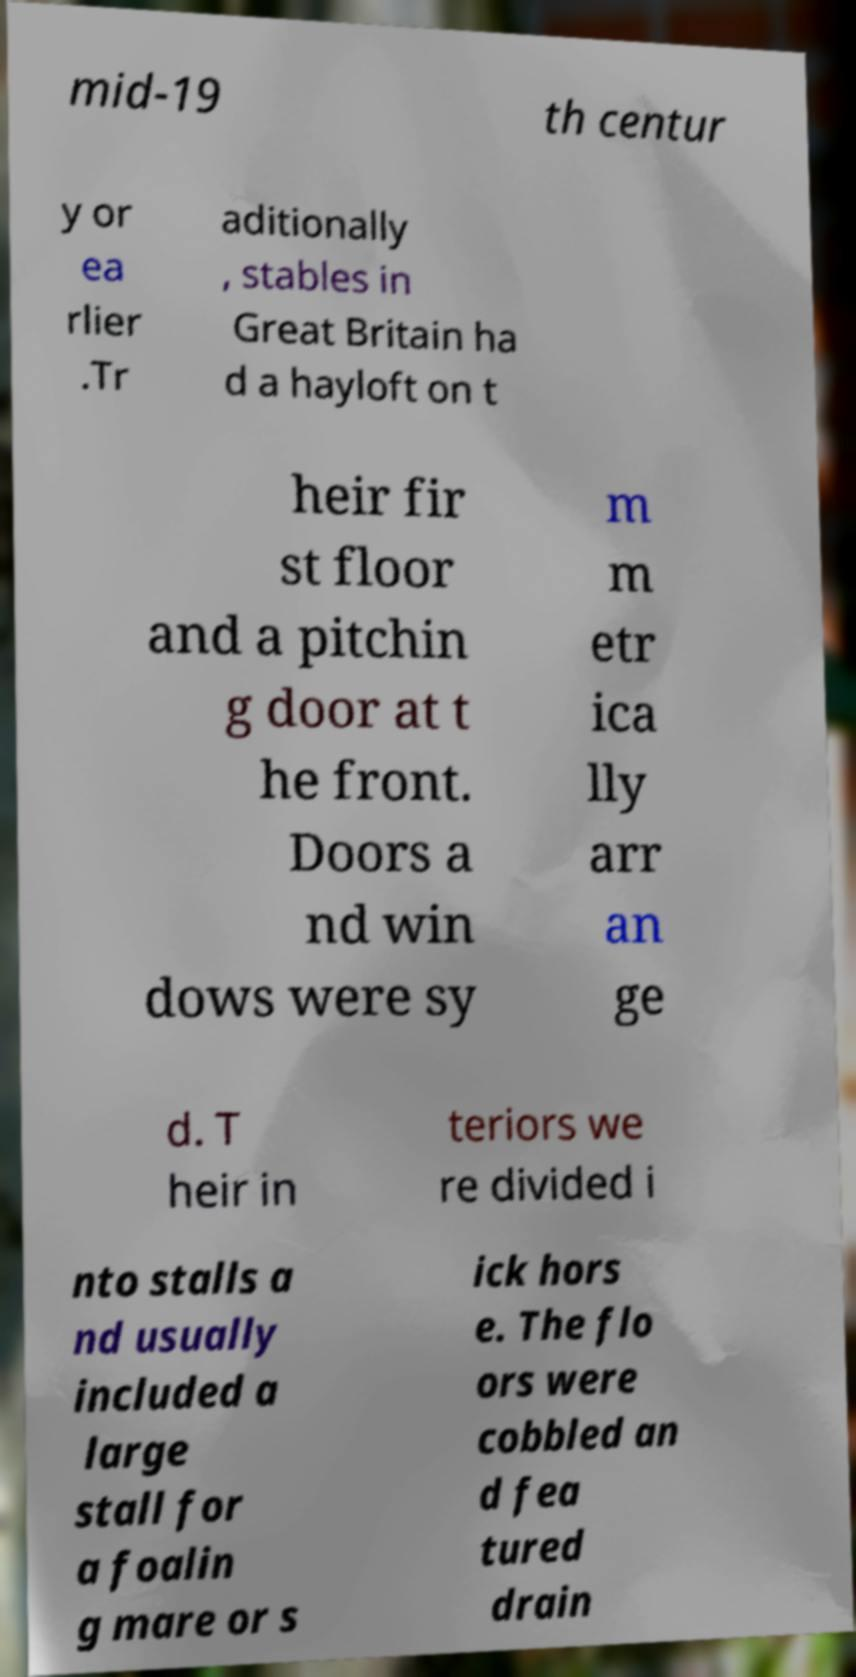Could you extract and type out the text from this image? mid-19 th centur y or ea rlier .Tr aditionally , stables in Great Britain ha d a hayloft on t heir fir st floor and a pitchin g door at t he front. Doors a nd win dows were sy m m etr ica lly arr an ge d. T heir in teriors we re divided i nto stalls a nd usually included a large stall for a foalin g mare or s ick hors e. The flo ors were cobbled an d fea tured drain 